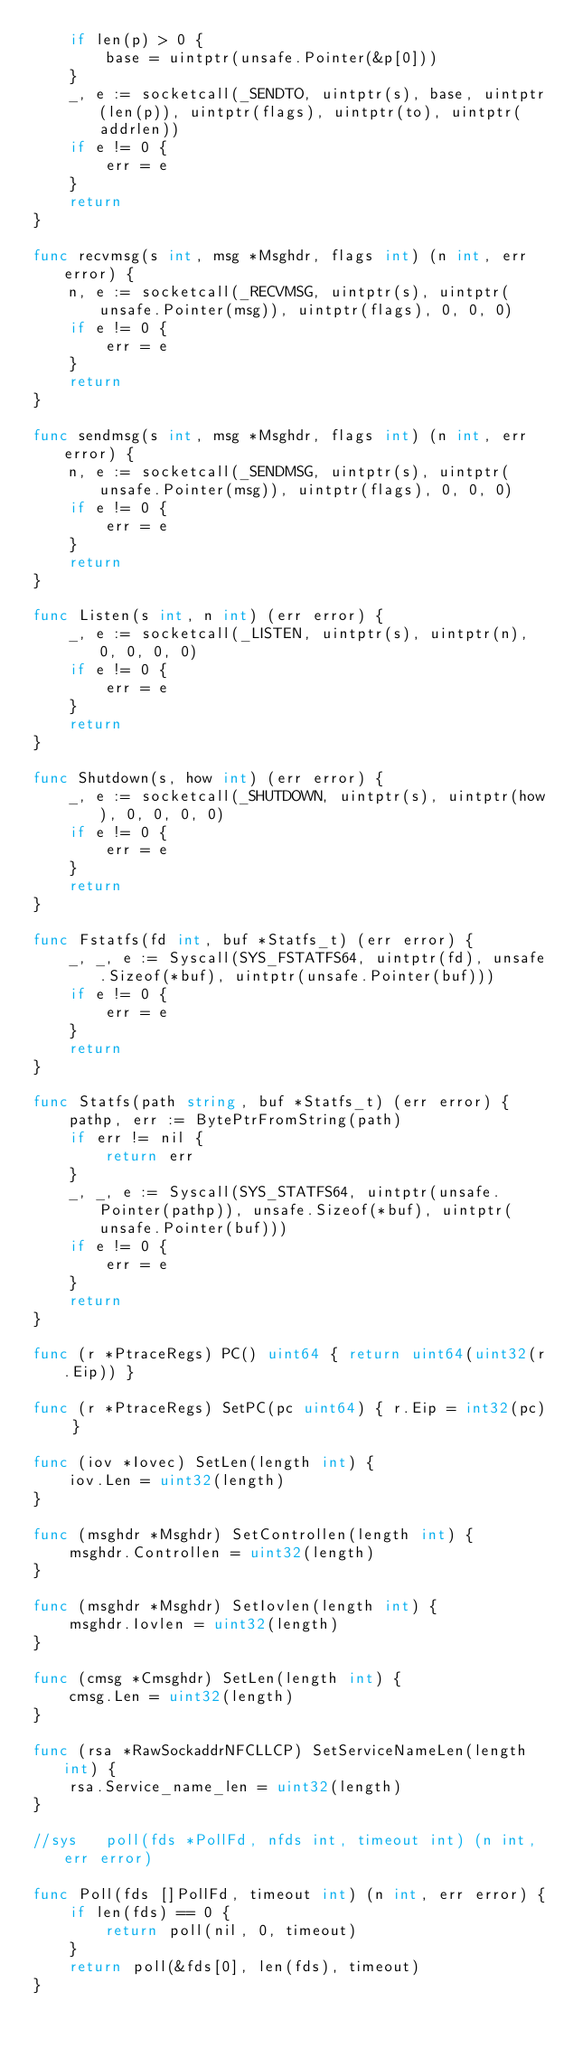Convert code to text. <code><loc_0><loc_0><loc_500><loc_500><_Go_>	if len(p) > 0 {
		base = uintptr(unsafe.Pointer(&p[0]))
	}
	_, e := socketcall(_SENDTO, uintptr(s), base, uintptr(len(p)), uintptr(flags), uintptr(to), uintptr(addrlen))
	if e != 0 {
		err = e
	}
	return
}

func recvmsg(s int, msg *Msghdr, flags int) (n int, err error) {
	n, e := socketcall(_RECVMSG, uintptr(s), uintptr(unsafe.Pointer(msg)), uintptr(flags), 0, 0, 0)
	if e != 0 {
		err = e
	}
	return
}

func sendmsg(s int, msg *Msghdr, flags int) (n int, err error) {
	n, e := socketcall(_SENDMSG, uintptr(s), uintptr(unsafe.Pointer(msg)), uintptr(flags), 0, 0, 0)
	if e != 0 {
		err = e
	}
	return
}

func Listen(s int, n int) (err error) {
	_, e := socketcall(_LISTEN, uintptr(s), uintptr(n), 0, 0, 0, 0)
	if e != 0 {
		err = e
	}
	return
}

func Shutdown(s, how int) (err error) {
	_, e := socketcall(_SHUTDOWN, uintptr(s), uintptr(how), 0, 0, 0, 0)
	if e != 0 {
		err = e
	}
	return
}

func Fstatfs(fd int, buf *Statfs_t) (err error) {
	_, _, e := Syscall(SYS_FSTATFS64, uintptr(fd), unsafe.Sizeof(*buf), uintptr(unsafe.Pointer(buf)))
	if e != 0 {
		err = e
	}
	return
}

func Statfs(path string, buf *Statfs_t) (err error) {
	pathp, err := BytePtrFromString(path)
	if err != nil {
		return err
	}
	_, _, e := Syscall(SYS_STATFS64, uintptr(unsafe.Pointer(pathp)), unsafe.Sizeof(*buf), uintptr(unsafe.Pointer(buf)))
	if e != 0 {
		err = e
	}
	return
}

func (r *PtraceRegs) PC() uint64 { return uint64(uint32(r.Eip)) }

func (r *PtraceRegs) SetPC(pc uint64) { r.Eip = int32(pc) }

func (iov *Iovec) SetLen(length int) {
	iov.Len = uint32(length)
}

func (msghdr *Msghdr) SetControllen(length int) {
	msghdr.Controllen = uint32(length)
}

func (msghdr *Msghdr) SetIovlen(length int) {
	msghdr.Iovlen = uint32(length)
}

func (cmsg *Cmsghdr) SetLen(length int) {
	cmsg.Len = uint32(length)
}

func (rsa *RawSockaddrNFCLLCP) SetServiceNameLen(length int) {
	rsa.Service_name_len = uint32(length)
}

//sys	poll(fds *PollFd, nfds int, timeout int) (n int, err error)

func Poll(fds []PollFd, timeout int) (n int, err error) {
	if len(fds) == 0 {
		return poll(nil, 0, timeout)
	}
	return poll(&fds[0], len(fds), timeout)
}
</code> 